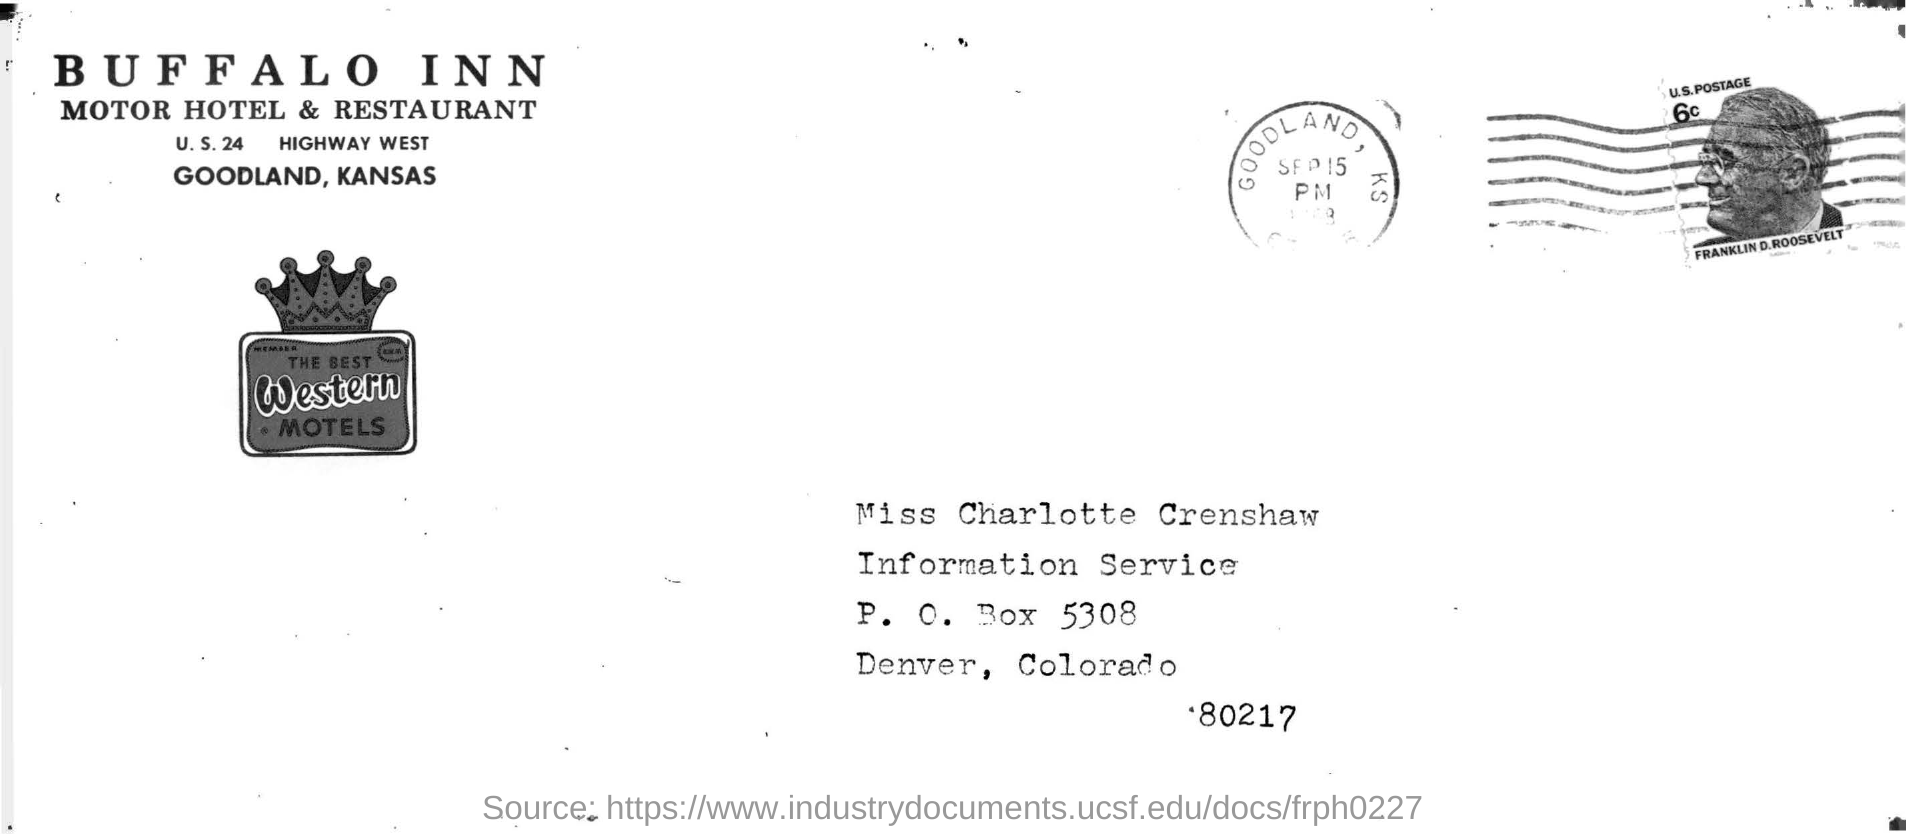What is the name of the hotel ?
Your response must be concise. Buffalo inn. Where is the buffalo inn motor hotel and restaurant located ?
Your answer should be compact. Goodland. 